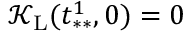<formula> <loc_0><loc_0><loc_500><loc_500>\mathcal { K } _ { L } ( t _ { * * } ^ { 1 } , 0 ) = 0</formula> 